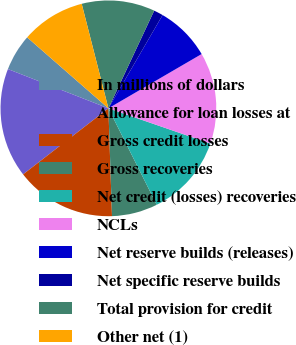Convert chart to OTSL. <chart><loc_0><loc_0><loc_500><loc_500><pie_chart><fcel>In millions of dollars<fcel>Allowance for loan losses at<fcel>Gross credit losses<fcel>Gross recoveries<fcel>Net credit (losses) recoveries<fcel>NCLs<fcel>Net reserve builds (releases)<fcel>Net specific reserve builds<fcel>Total provision for credit<fcel>Other net (1)<nl><fcel>5.5%<fcel>16.41%<fcel>15.05%<fcel>6.86%<fcel>12.32%<fcel>13.68%<fcel>8.23%<fcel>1.4%<fcel>10.96%<fcel>9.59%<nl></chart> 